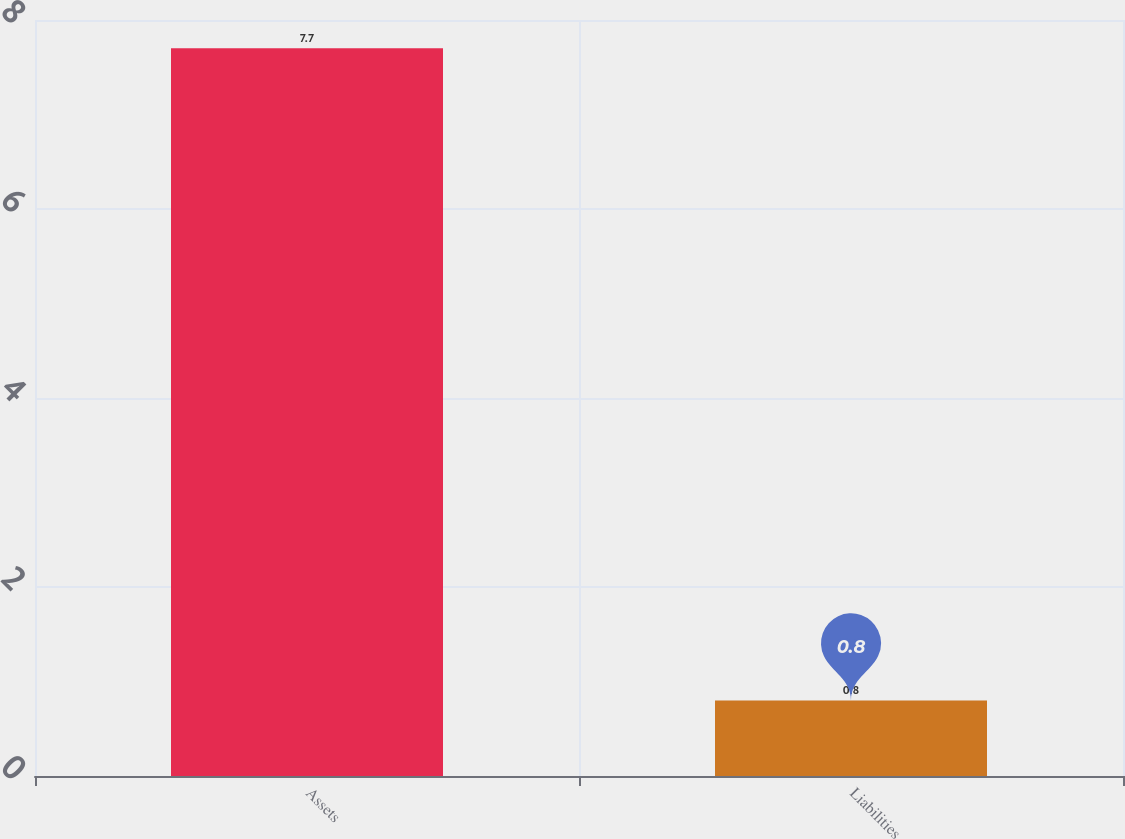Convert chart to OTSL. <chart><loc_0><loc_0><loc_500><loc_500><bar_chart><fcel>Assets<fcel>Liabilities<nl><fcel>7.7<fcel>0.8<nl></chart> 